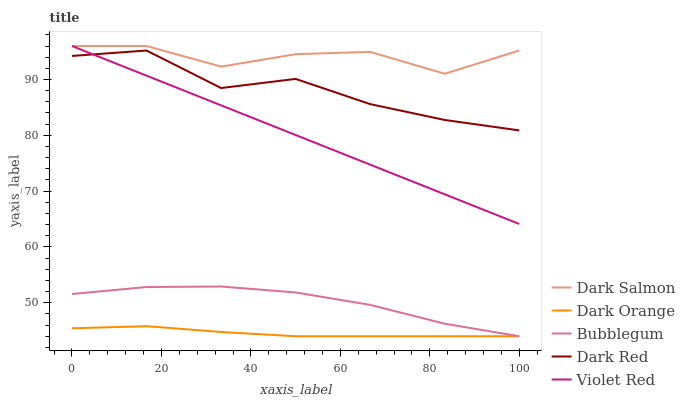Does Dark Orange have the minimum area under the curve?
Answer yes or no. Yes. Does Dark Salmon have the maximum area under the curve?
Answer yes or no. Yes. Does Violet Red have the minimum area under the curve?
Answer yes or no. No. Does Violet Red have the maximum area under the curve?
Answer yes or no. No. Is Violet Red the smoothest?
Answer yes or no. Yes. Is Dark Red the roughest?
Answer yes or no. Yes. Is Dark Salmon the smoothest?
Answer yes or no. No. Is Dark Salmon the roughest?
Answer yes or no. No. Does Dark Orange have the lowest value?
Answer yes or no. Yes. Does Violet Red have the lowest value?
Answer yes or no. No. Does Dark Salmon have the highest value?
Answer yes or no. Yes. Does Bubblegum have the highest value?
Answer yes or no. No. Is Bubblegum less than Dark Salmon?
Answer yes or no. Yes. Is Violet Red greater than Bubblegum?
Answer yes or no. Yes. Does Dark Orange intersect Bubblegum?
Answer yes or no. Yes. Is Dark Orange less than Bubblegum?
Answer yes or no. No. Is Dark Orange greater than Bubblegum?
Answer yes or no. No. Does Bubblegum intersect Dark Salmon?
Answer yes or no. No. 